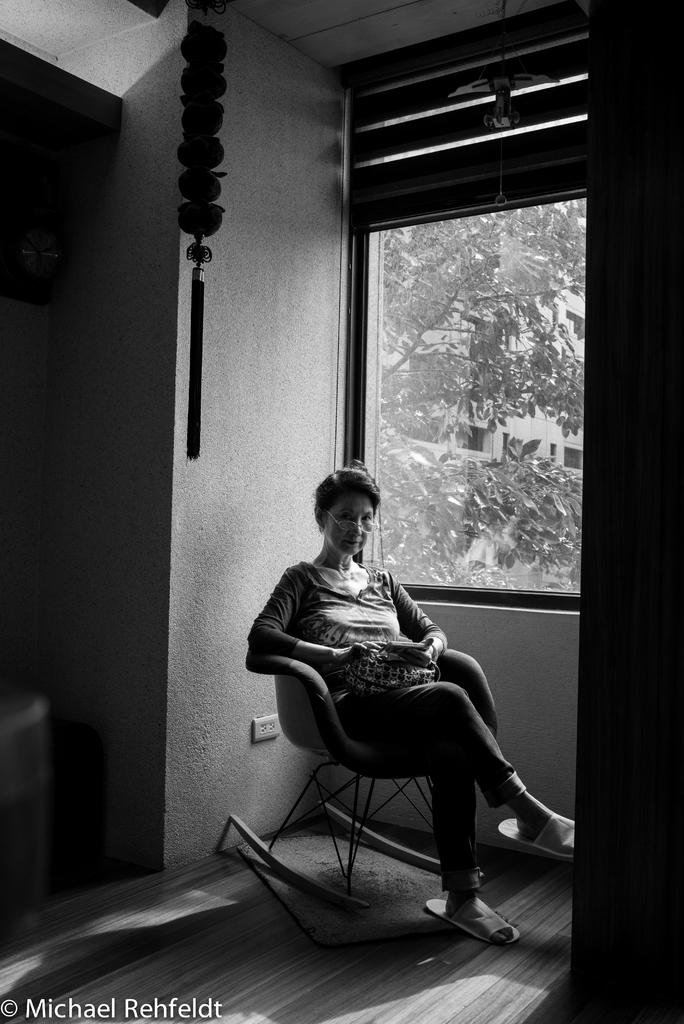Who is present in the image? There is a woman in the image. What is the woman doing in the image? The woman is sitting on a chair. What can be seen in the background of the image? There is a tree and a building in the background of the image. What type of poison is the woman holding in the image? There is no poison present in the image; the woman is simply sitting on a chair. 